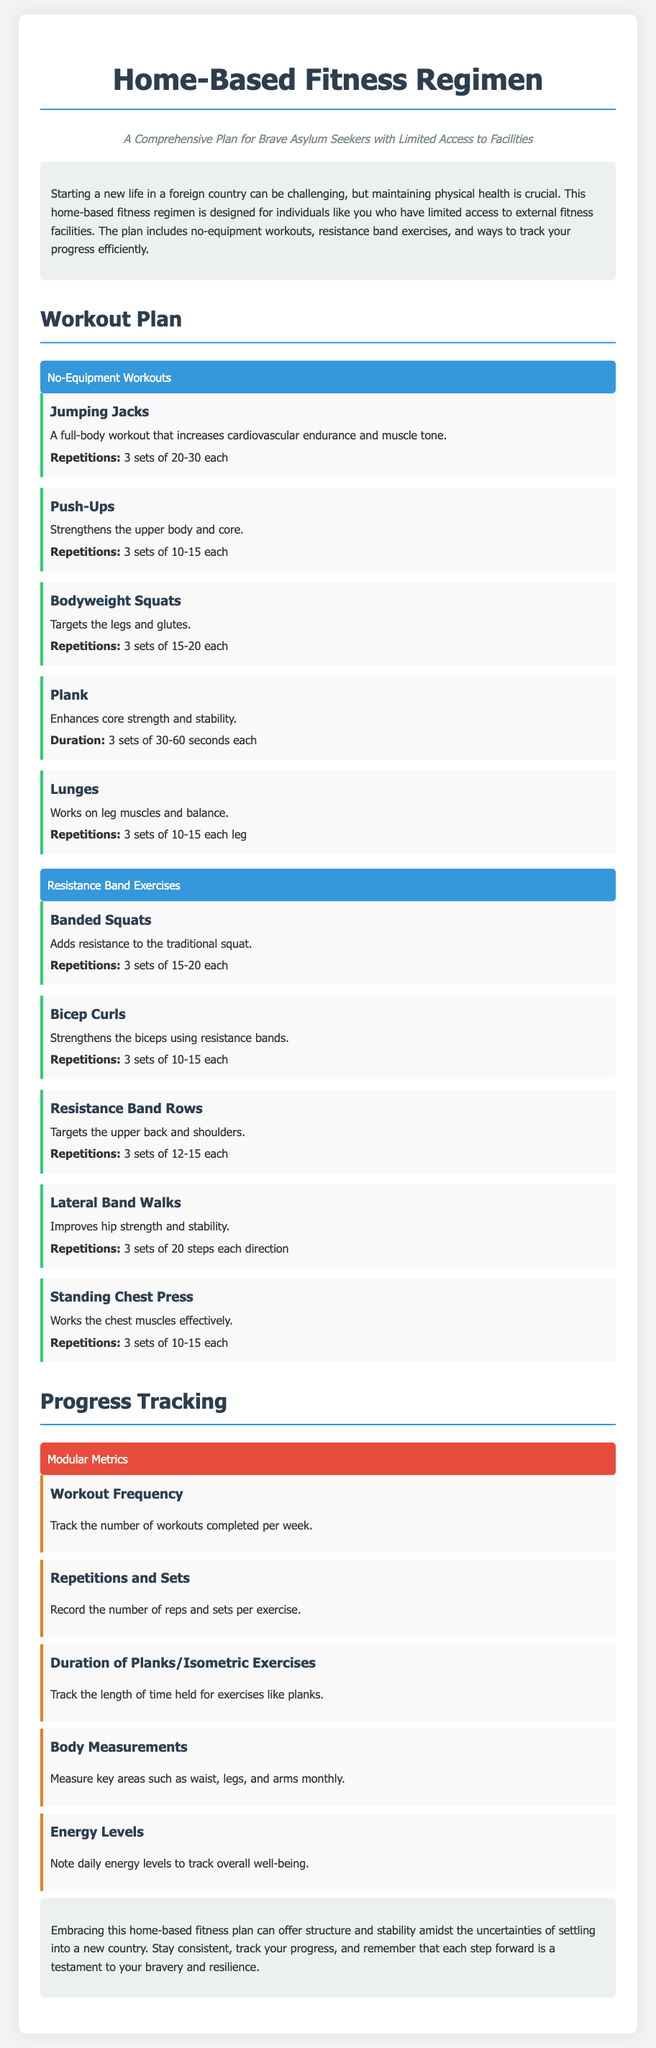What is the title of the document? The title is displayed prominently at the top of the document, which identifies the focus of the content.
Answer: Home-Based Fitness Regimen What type of workouts does the plan include? The document outlines various workout types included in the regimen, focusing on accessibility and resources needed.
Answer: No-equipment workouts, resistance band exercises How many sets of Jumping Jacks are recommended? The number of sets for Jumping Jacks is specified under the exercise section of the document.
Answer: 3 sets What is the duration for Planks suggested in the plan? The duration for Planks is specified in the description for the exercise, providing clear guidelines for the workout.
Answer: 3 sets of 30-60 seconds each What is the purpose of tracking body measurements? The document explains the reason for tracking body measurements as a way to monitor fitness progress and changes over time.
Answer: Measure key areas such as waist, legs, and arms monthly How many repetitions are recommended for Bicep Curls? The appropriate number of repetitions for Bicep Curls is provided, specified in the exercise section of the document.
Answer: 3 sets of 10-15 each Which section includes modular metrics for tracking progress? The section title indicates where progress tracking methods are discussed in relation to the workout plan.
Answer: Progress Tracking What does the conclusion emphasize? The conclusion summarizes the overall message of the document, reinforcing the importance of the fitness plan in a specific context.
Answer: Embracing this home-based fitness plan can offer structure and stability 